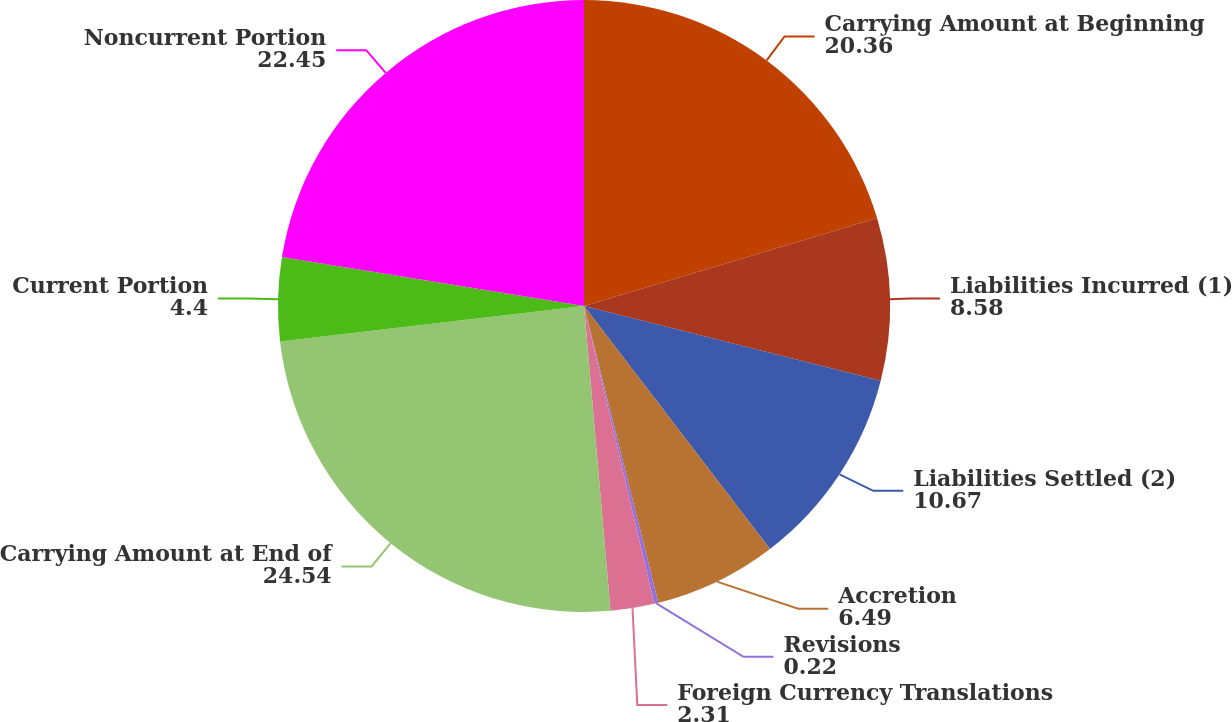Convert chart to OTSL. <chart><loc_0><loc_0><loc_500><loc_500><pie_chart><fcel>Carrying Amount at Beginning<fcel>Liabilities Incurred (1)<fcel>Liabilities Settled (2)<fcel>Accretion<fcel>Revisions<fcel>Foreign Currency Translations<fcel>Carrying Amount at End of<fcel>Current Portion<fcel>Noncurrent Portion<nl><fcel>20.36%<fcel>8.58%<fcel>10.67%<fcel>6.49%<fcel>0.22%<fcel>2.31%<fcel>24.54%<fcel>4.4%<fcel>22.45%<nl></chart> 